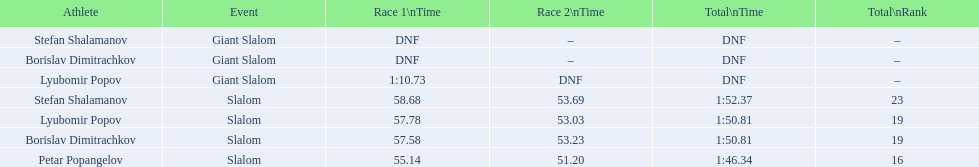What is the count of athletes who completed the first race in the giant slalom? 1. 